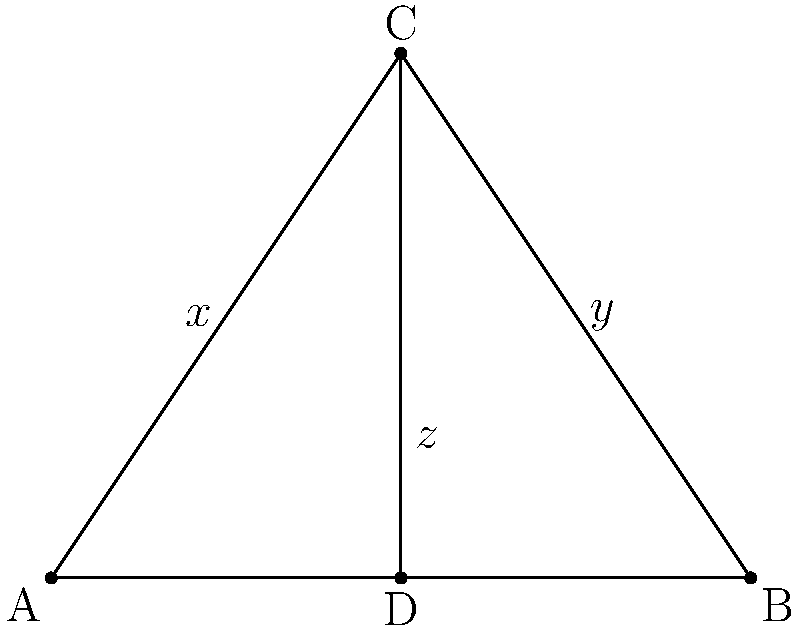In the divine plan represented by this triangle ABC, a line CD is drawn from the apex C to the base AB, symbolizing God's guidance. If angle $x = 40°$ and angle $y = 50°$, what is the measure of angle $z$, representing the harmony of God's creation? Let's approach this step-by-step, remembering that God's creation follows perfect mathematical principles:

1) In a triangle, the sum of all angles is always 180°. This represents the completeness of God's design.

2) The line CD creates two sets of angles: 
   - Angles $x$ and $y$ with the sides of the triangle
   - Angles on the base (including $z$) with AB

3) The angles on a straight line sum to 180°. This is true for the base AB, showcasing the perfection in God's plan.

4) We're given that $x = 40°$ and $y = 50°$

5) Let's call the angle between AC and CD as $a$, and the angle between BC and CD as $b$

6) From step 1: $a + b + 40° + 50° = 180°$
   $a + b = 90°$

7) From step 3, on the base AB: $a + b + z = 180°$

8) Substituting the value from step 6:
   $90° + z = 180°$
   $z = 180° - 90° = 90°$

Thus, we see how God's divine plan results in a perfect right angle at the base of the triangle.
Answer: $90°$ 